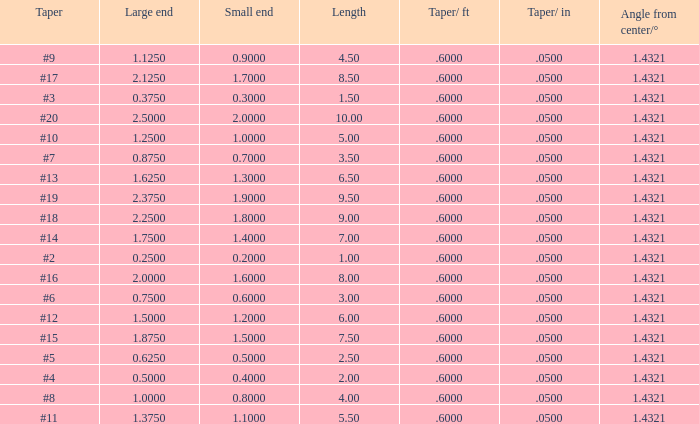875? None. 